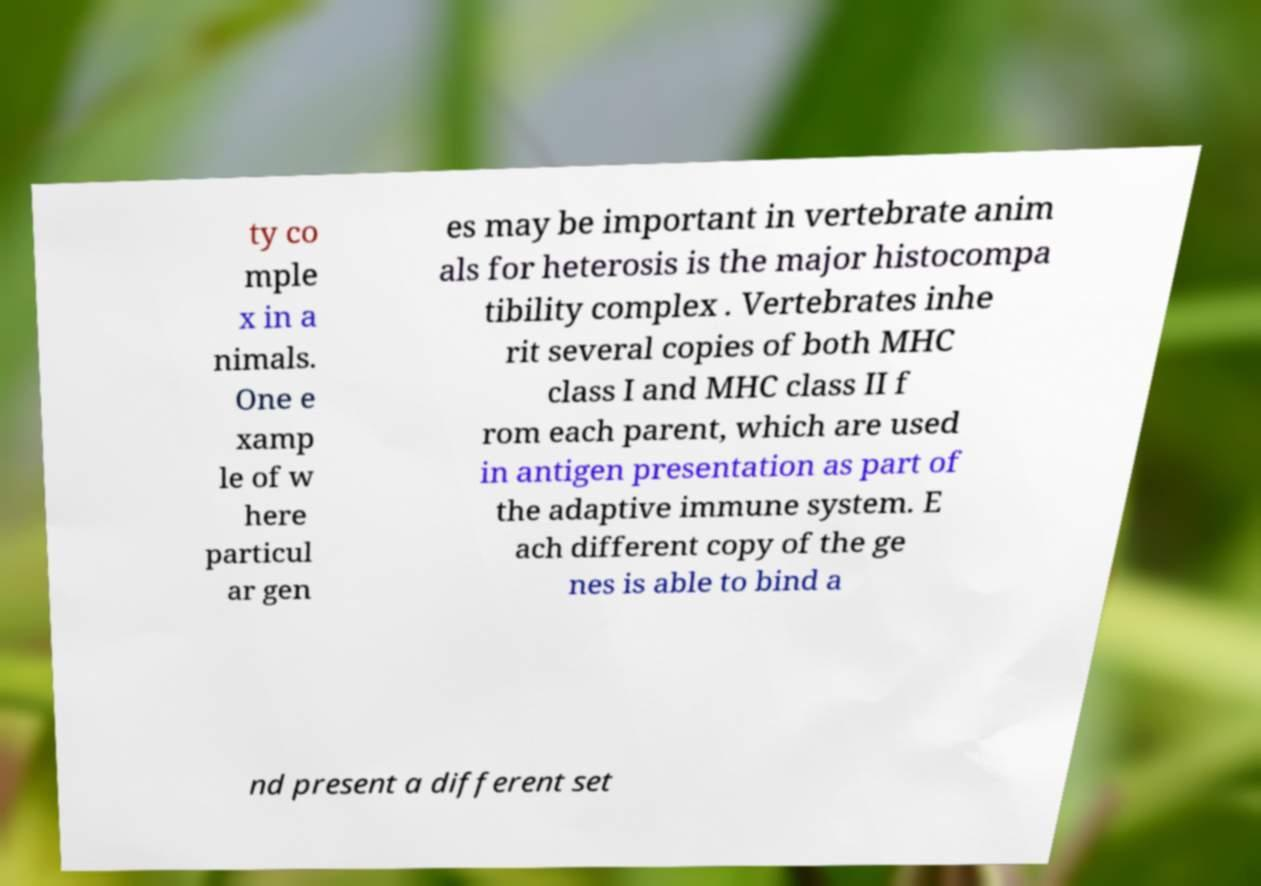I need the written content from this picture converted into text. Can you do that? ty co mple x in a nimals. One e xamp le of w here particul ar gen es may be important in vertebrate anim als for heterosis is the major histocompa tibility complex . Vertebrates inhe rit several copies of both MHC class I and MHC class II f rom each parent, which are used in antigen presentation as part of the adaptive immune system. E ach different copy of the ge nes is able to bind a nd present a different set 